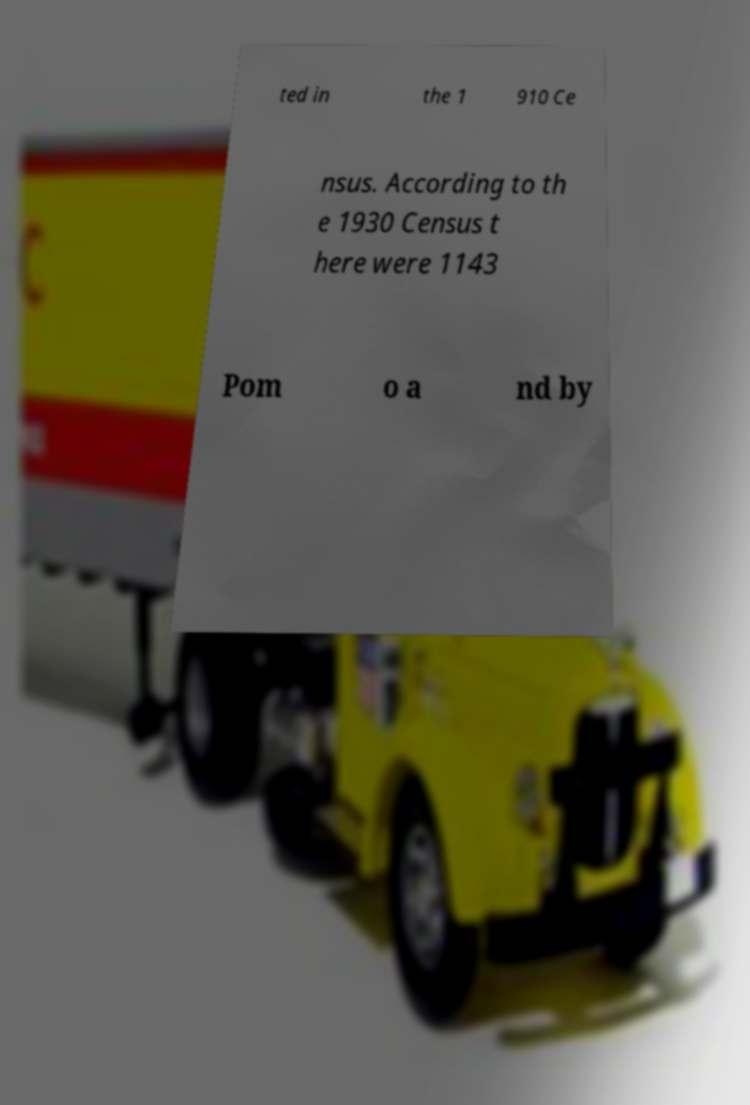I need the written content from this picture converted into text. Can you do that? ted in the 1 910 Ce nsus. According to th e 1930 Census t here were 1143 Pom o a nd by 